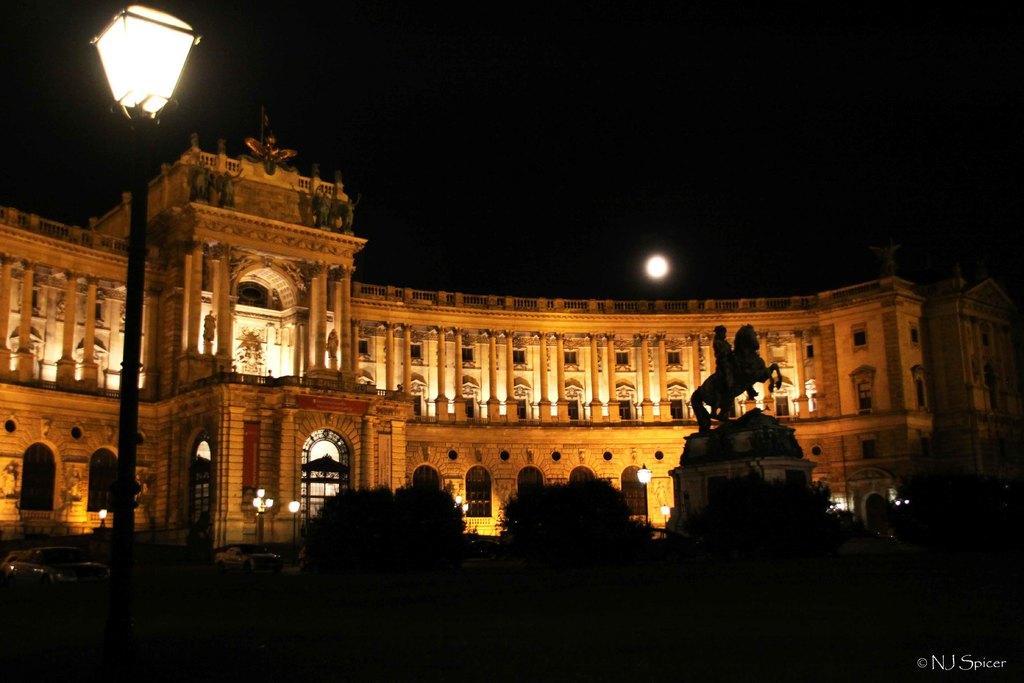Please provide a concise description of this image. In this image there is a building, light poles, statues, plants, vehicles, moon, dark sky and objects. At the bottom right side of the image there is a watermark. 